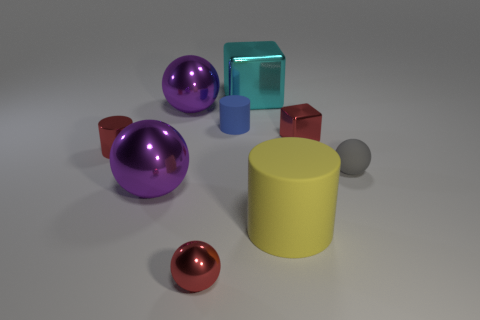Subtract all large cylinders. How many cylinders are left? 2 Subtract all green cubes. How many purple balls are left? 2 Subtract all gray spheres. How many spheres are left? 3 Add 1 small metallic blocks. How many objects exist? 10 Subtract all green cylinders. Subtract all blue cubes. How many cylinders are left? 3 Subtract all cubes. How many objects are left? 7 Add 4 big red matte balls. How many big red matte balls exist? 4 Subtract 0 yellow blocks. How many objects are left? 9 Subtract all small gray spheres. Subtract all big cubes. How many objects are left? 7 Add 6 yellow rubber things. How many yellow rubber things are left? 7 